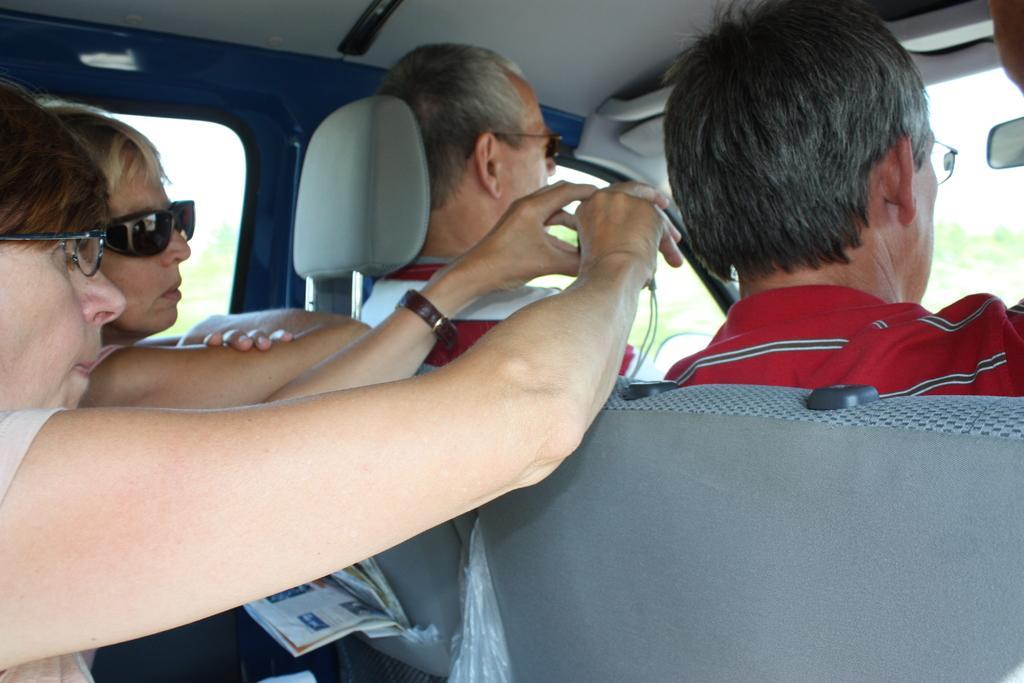In one or two sentences, can you explain what this image depicts? In the image I can see people are sitting in a vehicle. These people are wearing glasses. I can also see windows and some other objects in the vehicle. This is an inside view of a vehicle where we can see the trees through windows. 